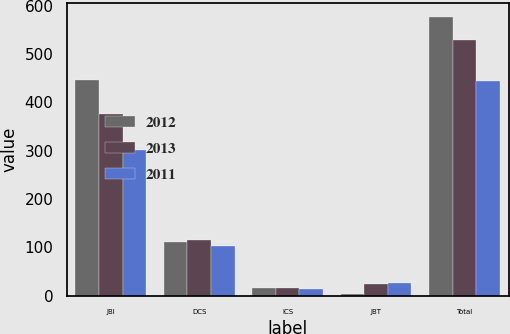Convert chart. <chart><loc_0><loc_0><loc_500><loc_500><stacked_bar_chart><ecel><fcel>JBI<fcel>DCS<fcel>ICS<fcel>JBT<fcel>Total<nl><fcel>2012<fcel>447<fcel>110<fcel>16<fcel>4<fcel>577<nl><fcel>2013<fcel>375<fcel>116<fcel>16<fcel>23<fcel>530<nl><fcel>2011<fcel>301<fcel>103<fcel>13<fcel>27<fcel>444<nl></chart> 